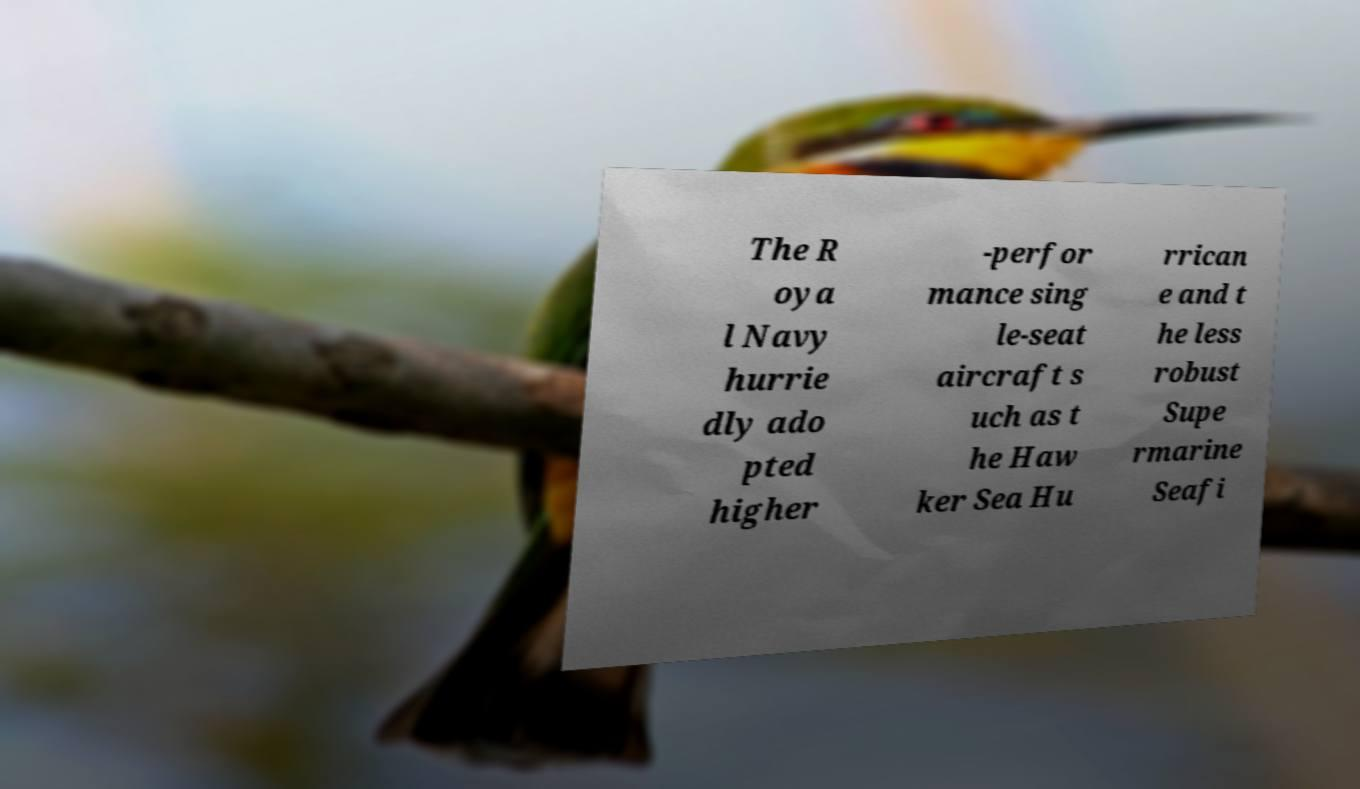Can you accurately transcribe the text from the provided image for me? The R oya l Navy hurrie dly ado pted higher -perfor mance sing le-seat aircraft s uch as t he Haw ker Sea Hu rrican e and t he less robust Supe rmarine Seafi 